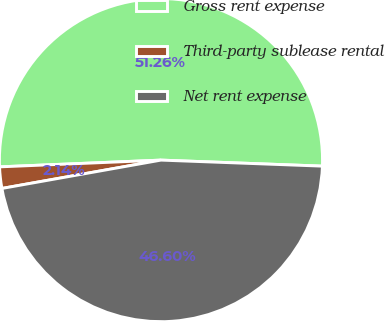Convert chart to OTSL. <chart><loc_0><loc_0><loc_500><loc_500><pie_chart><fcel>Gross rent expense<fcel>Third-party sublease rental<fcel>Net rent expense<nl><fcel>51.26%<fcel>2.14%<fcel>46.6%<nl></chart> 